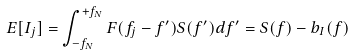<formula> <loc_0><loc_0><loc_500><loc_500>E [ I _ { j } ] = \int _ { - f _ { N } } ^ { + f _ { N } } F ( f _ { j } - f ^ { \prime } ) S ( f ^ { \prime } ) d f ^ { \prime } = S ( f ) - b _ { I } ( f )</formula> 